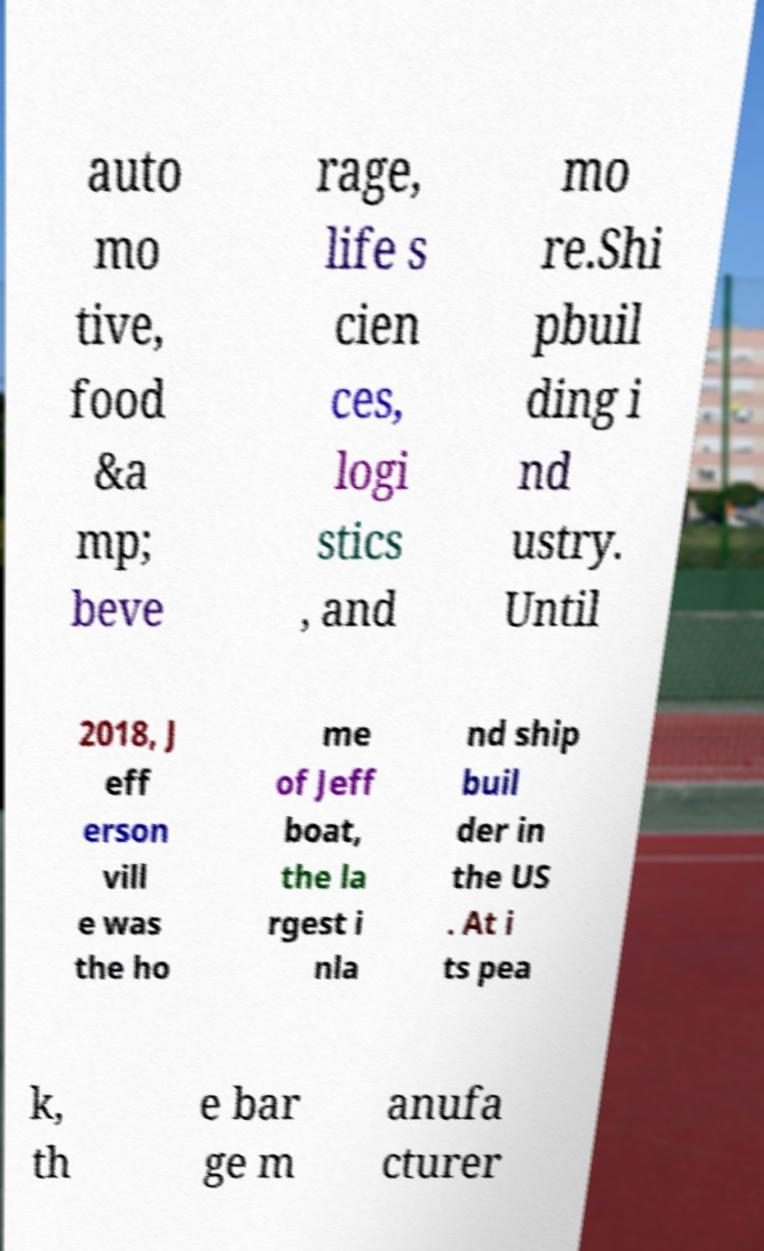For documentation purposes, I need the text within this image transcribed. Could you provide that? auto mo tive, food &a mp; beve rage, life s cien ces, logi stics , and mo re.Shi pbuil ding i nd ustry. Until 2018, J eff erson vill e was the ho me of Jeff boat, the la rgest i nla nd ship buil der in the US . At i ts pea k, th e bar ge m anufa cturer 